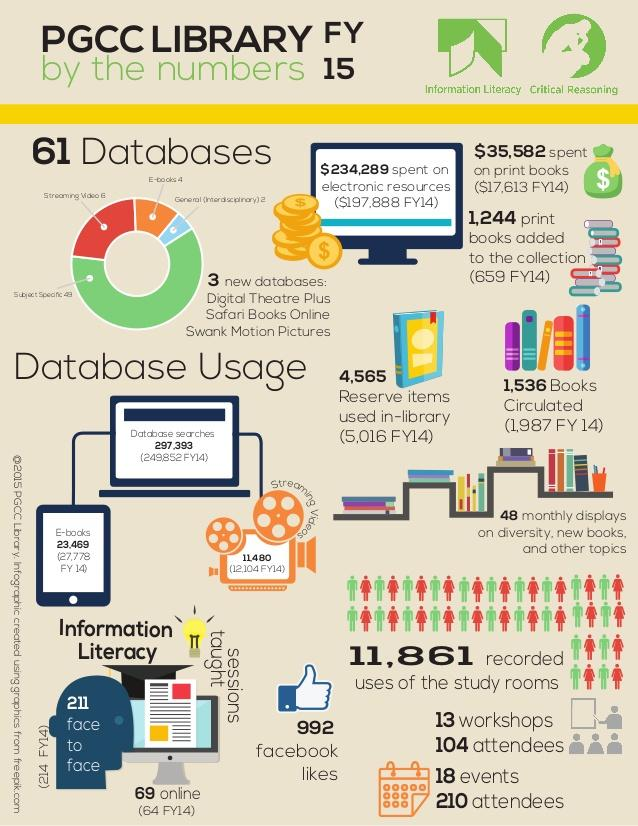Point out several critical features in this image. The search of databases yielded a total of 297,393 results. 